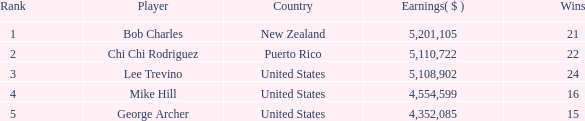In total, how much did the United States player George Archer earn with Wins lower than 24 and a rank that was higher than 5? 0.0. 